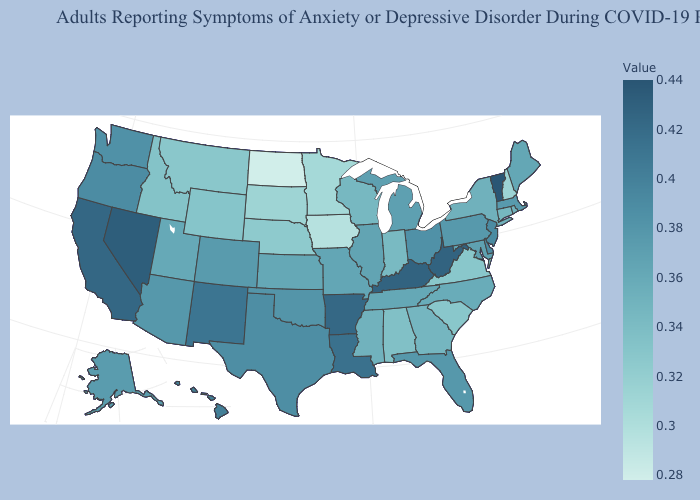Which states hav the highest value in the MidWest?
Write a very short answer. Ohio. Which states have the highest value in the USA?
Quick response, please. Vermont. Which states have the lowest value in the Northeast?
Answer briefly. New Hampshire. Does Idaho have the lowest value in the USA?
Short answer required. No. 